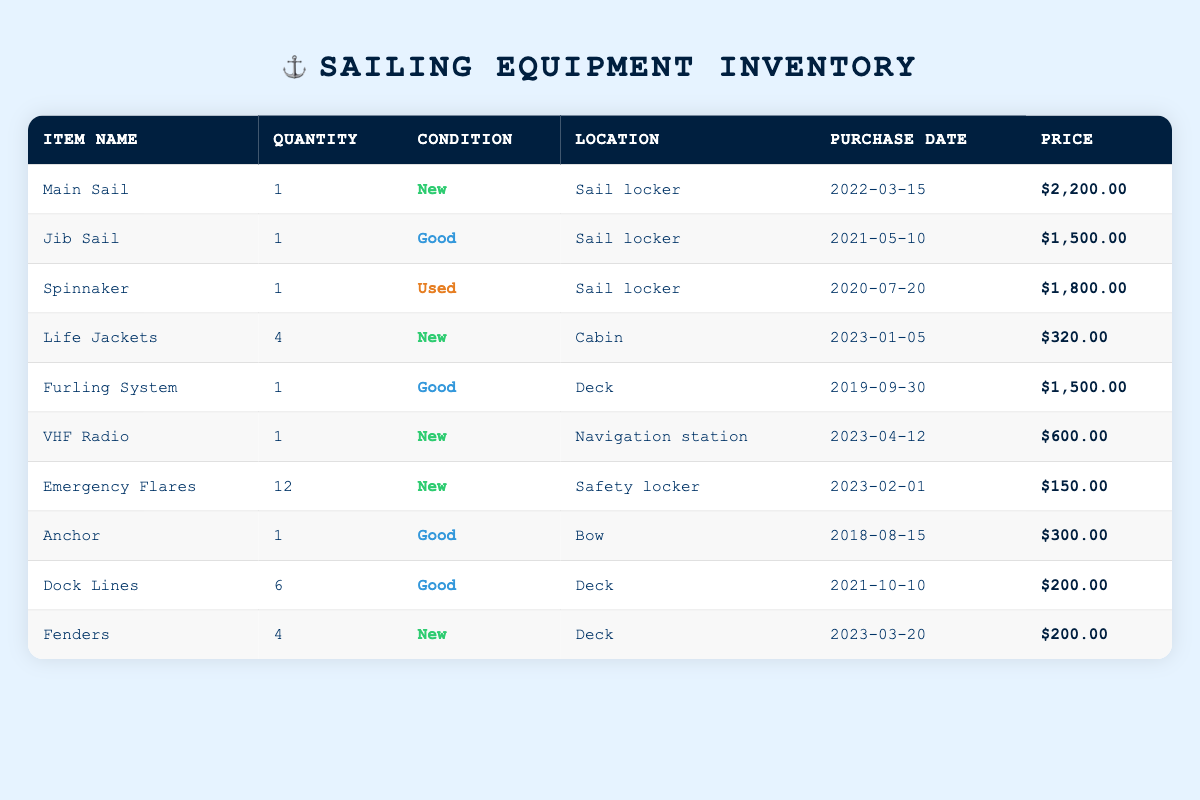What is the condition of the VHF Radio? The row corresponding to the VHF Radio indicates that its condition is listed as "New."
Answer: New How many Life Jackets are available? The quantity listed in the Life Jackets row is 4.
Answer: 4 What is the total price of all the New items in the inventory? The New items include Main Sail ($2,200), Life Jackets ($320 for 4), VHF Radio ($600), Emergency Flares ($150 for 12), and Fenders ($200 for 4). Adding these up: 2200 + 320 + 600 + 150 + 200 = 3580.
Answer: 3580 Is there more than one Jib Sail in the inventory? The quantity of Jib Sail is listed as 1, which indicates there is no more than one.
Answer: No How many Good condition items are in the inventory? The items with "Good" condition are Jib Sail, Furling System, Anchor, and Dock Lines. This totals to 4 items.
Answer: 4 Which item has the highest price? The Main Sail has the highest price at $2,200.
Answer: Main Sail What is the average price of the equipment stored in the Sail locker? The items in the Sail locker are Main Sail ($2,200), Jib Sail ($1,500), and Spinnaker ($1,800). First, sum the prices: 2200 + 1500 + 1800 = 5500. There are 3 items, so the average is 5500 / 3 = 1833.33.
Answer: 1833.33 Has any item been purchased in the last three months? The Life Jackets, VHF Radio, and Emergency Flares were purchased in January, April, and February 2023 respectively. Therefore, there are items purchased in the last three months.
Answer: Yes What is the total quantity of items stored on the Deck? The items on the Deck are the Furling System (1), Dock Lines (6), and Fenders (4). The total quantity is 1 + 6 + 4 = 11.
Answer: 11 